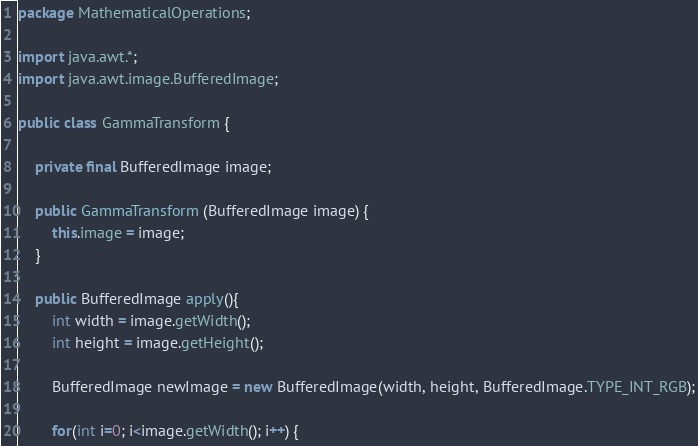Convert code to text. <code><loc_0><loc_0><loc_500><loc_500><_Java_>package MathematicalOperations;

import java.awt.*;
import java.awt.image.BufferedImage;

public class GammaTransform {

    private final BufferedImage image;

    public GammaTransform (BufferedImage image) {
        this.image = image;
    }

    public BufferedImage apply(){
        int width = image.getWidth();
        int height = image.getHeight();

        BufferedImage newImage = new BufferedImage(width, height, BufferedImage.TYPE_INT_RGB);

        for(int i=0; i<image.getWidth(); i++) {</code> 